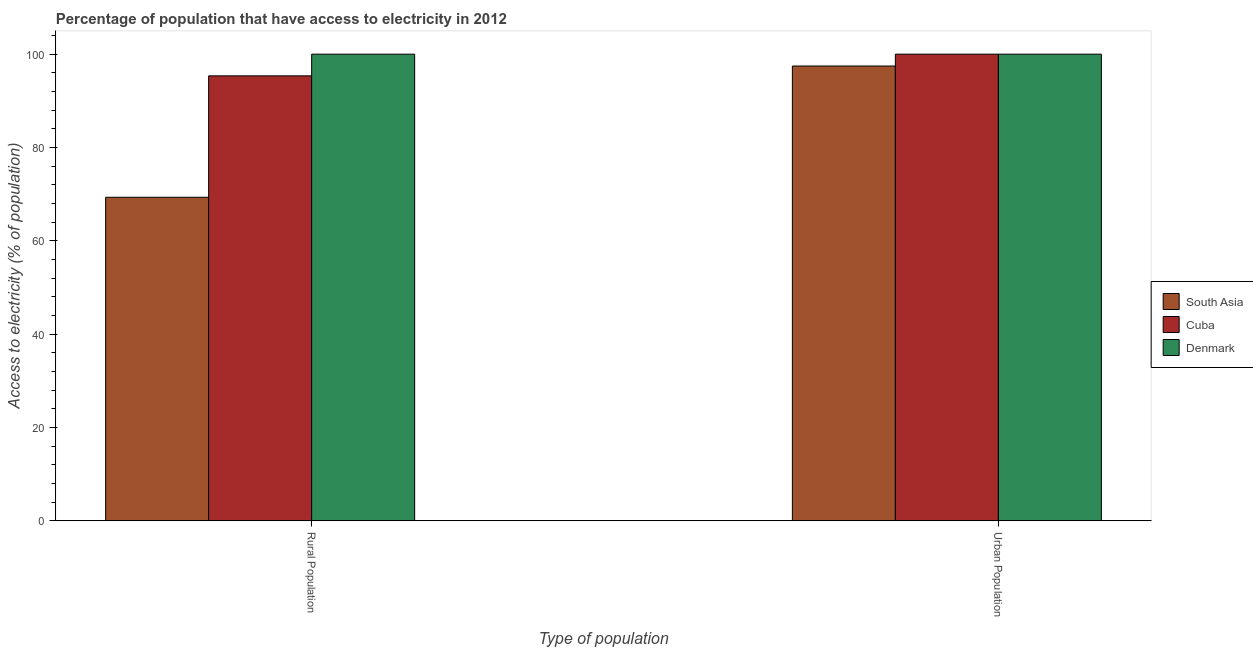How many different coloured bars are there?
Your answer should be very brief. 3. How many bars are there on the 2nd tick from the right?
Make the answer very short. 3. What is the label of the 1st group of bars from the left?
Ensure brevity in your answer.  Rural Population. What is the percentage of urban population having access to electricity in South Asia?
Your response must be concise. 97.46. Across all countries, what is the minimum percentage of urban population having access to electricity?
Offer a terse response. 97.46. In which country was the percentage of urban population having access to electricity maximum?
Your answer should be very brief. Cuba. What is the total percentage of urban population having access to electricity in the graph?
Give a very brief answer. 297.46. What is the difference between the percentage of urban population having access to electricity in South Asia and that in Denmark?
Keep it short and to the point. -2.54. What is the average percentage of rural population having access to electricity per country?
Provide a succinct answer. 88.23. What is the difference between the percentage of urban population having access to electricity and percentage of rural population having access to electricity in South Asia?
Your response must be concise. 28.12. In how many countries, is the percentage of rural population having access to electricity greater than 8 %?
Provide a short and direct response. 3. What is the ratio of the percentage of rural population having access to electricity in South Asia to that in Denmark?
Offer a terse response. 0.69. In how many countries, is the percentage of urban population having access to electricity greater than the average percentage of urban population having access to electricity taken over all countries?
Offer a terse response. 2. What does the 2nd bar from the right in Urban Population represents?
Your answer should be very brief. Cuba. Are all the bars in the graph horizontal?
Give a very brief answer. No. What is the difference between two consecutive major ticks on the Y-axis?
Your response must be concise. 20. Does the graph contain grids?
Offer a terse response. No. What is the title of the graph?
Your response must be concise. Percentage of population that have access to electricity in 2012. What is the label or title of the X-axis?
Offer a terse response. Type of population. What is the label or title of the Y-axis?
Ensure brevity in your answer.  Access to electricity (% of population). What is the Access to electricity (% of population) of South Asia in Rural Population?
Your answer should be very brief. 69.34. What is the Access to electricity (% of population) of Cuba in Rural Population?
Your answer should be compact. 95.35. What is the Access to electricity (% of population) in South Asia in Urban Population?
Your answer should be very brief. 97.46. What is the Access to electricity (% of population) of Cuba in Urban Population?
Provide a succinct answer. 100. Across all Type of population, what is the maximum Access to electricity (% of population) of South Asia?
Your answer should be compact. 97.46. Across all Type of population, what is the maximum Access to electricity (% of population) of Cuba?
Offer a terse response. 100. Across all Type of population, what is the minimum Access to electricity (% of population) in South Asia?
Your answer should be very brief. 69.34. Across all Type of population, what is the minimum Access to electricity (% of population) of Cuba?
Offer a terse response. 95.35. What is the total Access to electricity (% of population) of South Asia in the graph?
Ensure brevity in your answer.  166.8. What is the total Access to electricity (% of population) of Cuba in the graph?
Provide a short and direct response. 195.35. What is the total Access to electricity (% of population) of Denmark in the graph?
Make the answer very short. 200. What is the difference between the Access to electricity (% of population) in South Asia in Rural Population and that in Urban Population?
Keep it short and to the point. -28.12. What is the difference between the Access to electricity (% of population) of Cuba in Rural Population and that in Urban Population?
Make the answer very short. -4.65. What is the difference between the Access to electricity (% of population) of Denmark in Rural Population and that in Urban Population?
Offer a terse response. 0. What is the difference between the Access to electricity (% of population) of South Asia in Rural Population and the Access to electricity (% of population) of Cuba in Urban Population?
Make the answer very short. -30.66. What is the difference between the Access to electricity (% of population) of South Asia in Rural Population and the Access to electricity (% of population) of Denmark in Urban Population?
Offer a terse response. -30.66. What is the difference between the Access to electricity (% of population) in Cuba in Rural Population and the Access to electricity (% of population) in Denmark in Urban Population?
Offer a terse response. -4.65. What is the average Access to electricity (% of population) of South Asia per Type of population?
Your answer should be compact. 83.4. What is the average Access to electricity (% of population) of Cuba per Type of population?
Offer a very short reply. 97.68. What is the average Access to electricity (% of population) of Denmark per Type of population?
Offer a very short reply. 100. What is the difference between the Access to electricity (% of population) in South Asia and Access to electricity (% of population) in Cuba in Rural Population?
Keep it short and to the point. -26.01. What is the difference between the Access to electricity (% of population) in South Asia and Access to electricity (% of population) in Denmark in Rural Population?
Your answer should be very brief. -30.66. What is the difference between the Access to electricity (% of population) of Cuba and Access to electricity (% of population) of Denmark in Rural Population?
Offer a terse response. -4.65. What is the difference between the Access to electricity (% of population) in South Asia and Access to electricity (% of population) in Cuba in Urban Population?
Make the answer very short. -2.54. What is the difference between the Access to electricity (% of population) in South Asia and Access to electricity (% of population) in Denmark in Urban Population?
Provide a succinct answer. -2.54. What is the difference between the Access to electricity (% of population) in Cuba and Access to electricity (% of population) in Denmark in Urban Population?
Give a very brief answer. 0. What is the ratio of the Access to electricity (% of population) in South Asia in Rural Population to that in Urban Population?
Offer a very short reply. 0.71. What is the ratio of the Access to electricity (% of population) in Cuba in Rural Population to that in Urban Population?
Keep it short and to the point. 0.95. What is the difference between the highest and the second highest Access to electricity (% of population) of South Asia?
Offer a very short reply. 28.12. What is the difference between the highest and the second highest Access to electricity (% of population) in Cuba?
Offer a terse response. 4.65. What is the difference between the highest and the second highest Access to electricity (% of population) in Denmark?
Offer a terse response. 0. What is the difference between the highest and the lowest Access to electricity (% of population) in South Asia?
Give a very brief answer. 28.12. What is the difference between the highest and the lowest Access to electricity (% of population) of Cuba?
Your answer should be compact. 4.65. What is the difference between the highest and the lowest Access to electricity (% of population) in Denmark?
Keep it short and to the point. 0. 